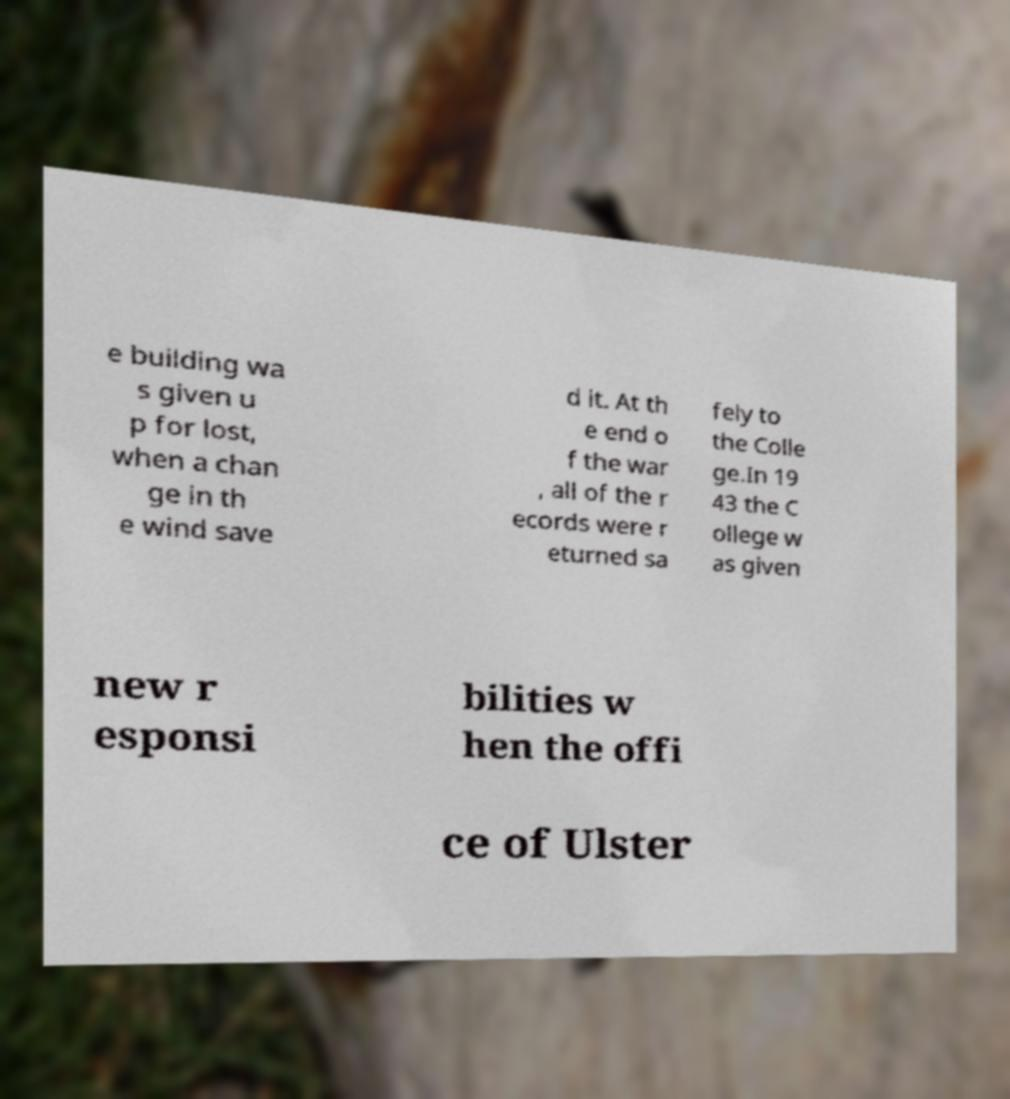Can you accurately transcribe the text from the provided image for me? e building wa s given u p for lost, when a chan ge in th e wind save d it. At th e end o f the war , all of the r ecords were r eturned sa fely to the Colle ge.In 19 43 the C ollege w as given new r esponsi bilities w hen the offi ce of Ulster 